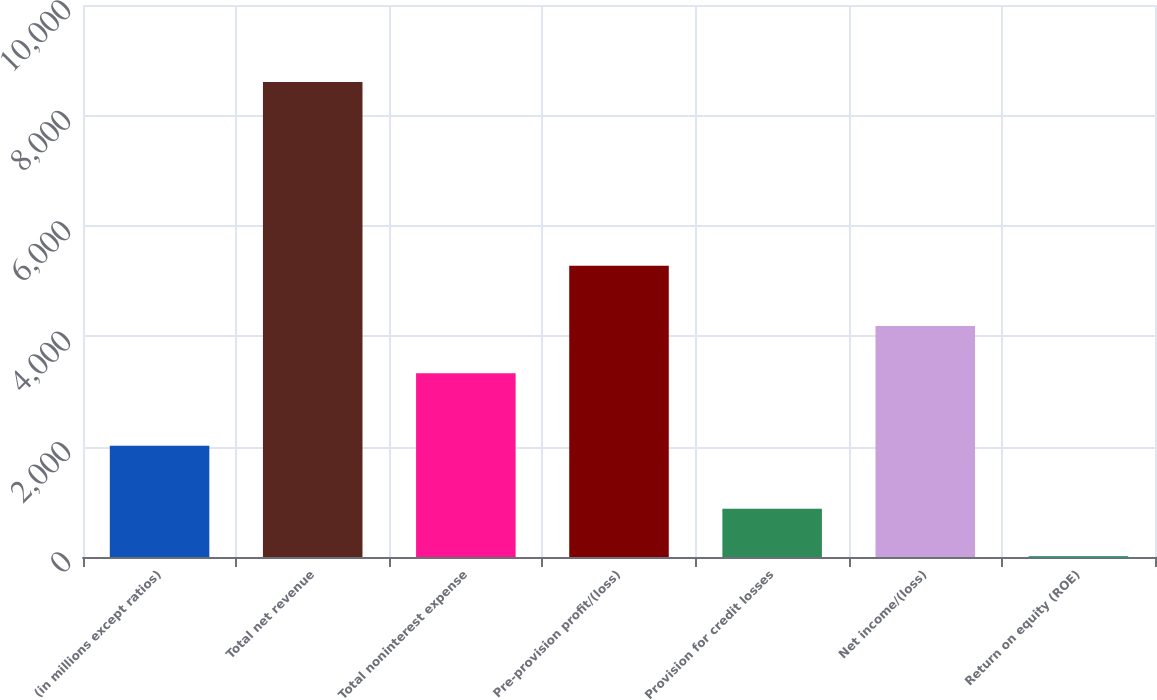Convert chart to OTSL. <chart><loc_0><loc_0><loc_500><loc_500><bar_chart><fcel>(in millions except ratios)<fcel>Total net revenue<fcel>Total noninterest expense<fcel>Pre-provision profit/(loss)<fcel>Provision for credit losses<fcel>Net income/(loss)<fcel>Return on equity (ROE)<nl><fcel>2017<fcel>8605<fcel>3327<fcel>5278<fcel>875.8<fcel>4185.8<fcel>17<nl></chart> 